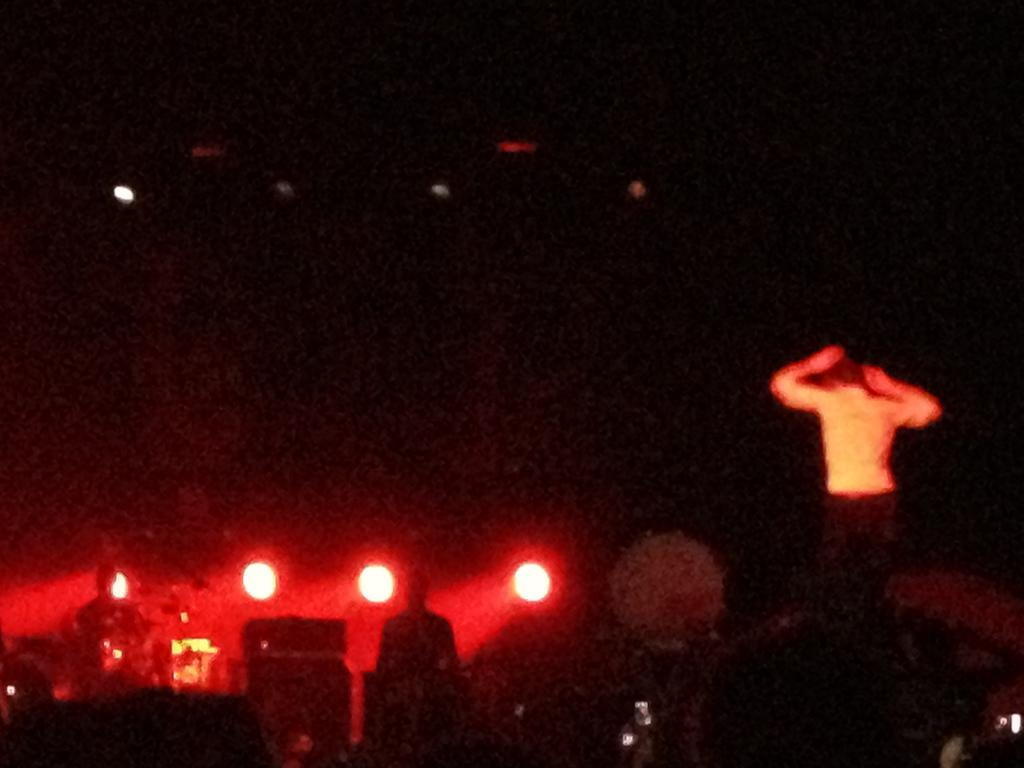How many people are present in the image? There are two people standing in the image. What is the setting of the image? It is likely a stage performance, as show lights are visible. What is the lighting condition in the image? The background appears dark in the image. Can you describe any objects or features in the background? There is a possible tree in the background of the image. What type of nest can be seen in the image? There is no nest present in the image; it features a stage performance with two people and show lights. 